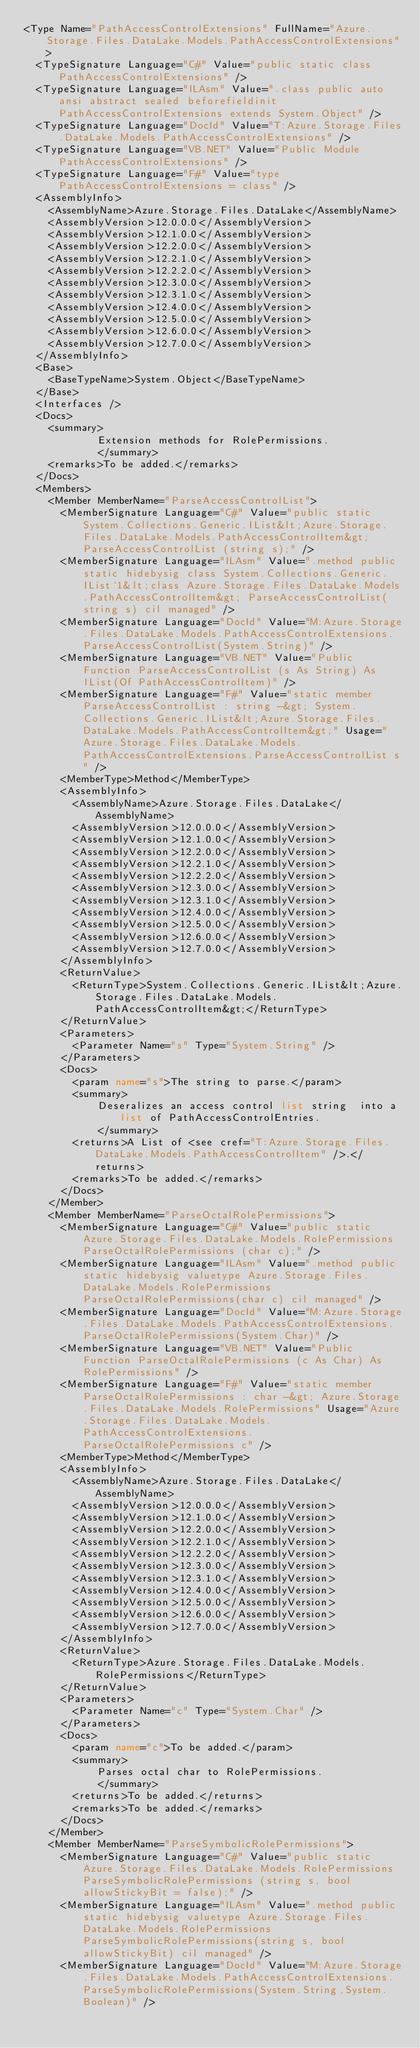Convert code to text. <code><loc_0><loc_0><loc_500><loc_500><_XML_><Type Name="PathAccessControlExtensions" FullName="Azure.Storage.Files.DataLake.Models.PathAccessControlExtensions">
  <TypeSignature Language="C#" Value="public static class PathAccessControlExtensions" />
  <TypeSignature Language="ILAsm" Value=".class public auto ansi abstract sealed beforefieldinit PathAccessControlExtensions extends System.Object" />
  <TypeSignature Language="DocId" Value="T:Azure.Storage.Files.DataLake.Models.PathAccessControlExtensions" />
  <TypeSignature Language="VB.NET" Value="Public Module PathAccessControlExtensions" />
  <TypeSignature Language="F#" Value="type PathAccessControlExtensions = class" />
  <AssemblyInfo>
    <AssemblyName>Azure.Storage.Files.DataLake</AssemblyName>
    <AssemblyVersion>12.0.0.0</AssemblyVersion>
    <AssemblyVersion>12.1.0.0</AssemblyVersion>
    <AssemblyVersion>12.2.0.0</AssemblyVersion>
    <AssemblyVersion>12.2.1.0</AssemblyVersion>
    <AssemblyVersion>12.2.2.0</AssemblyVersion>
    <AssemblyVersion>12.3.0.0</AssemblyVersion>
    <AssemblyVersion>12.3.1.0</AssemblyVersion>
    <AssemblyVersion>12.4.0.0</AssemblyVersion>
    <AssemblyVersion>12.5.0.0</AssemblyVersion>
    <AssemblyVersion>12.6.0.0</AssemblyVersion>
    <AssemblyVersion>12.7.0.0</AssemblyVersion>
  </AssemblyInfo>
  <Base>
    <BaseTypeName>System.Object</BaseTypeName>
  </Base>
  <Interfaces />
  <Docs>
    <summary>
            Extension methods for RolePermissions.
            </summary>
    <remarks>To be added.</remarks>
  </Docs>
  <Members>
    <Member MemberName="ParseAccessControlList">
      <MemberSignature Language="C#" Value="public static System.Collections.Generic.IList&lt;Azure.Storage.Files.DataLake.Models.PathAccessControlItem&gt; ParseAccessControlList (string s);" />
      <MemberSignature Language="ILAsm" Value=".method public static hidebysig class System.Collections.Generic.IList`1&lt;class Azure.Storage.Files.DataLake.Models.PathAccessControlItem&gt; ParseAccessControlList(string s) cil managed" />
      <MemberSignature Language="DocId" Value="M:Azure.Storage.Files.DataLake.Models.PathAccessControlExtensions.ParseAccessControlList(System.String)" />
      <MemberSignature Language="VB.NET" Value="Public Function ParseAccessControlList (s As String) As IList(Of PathAccessControlItem)" />
      <MemberSignature Language="F#" Value="static member ParseAccessControlList : string -&gt; System.Collections.Generic.IList&lt;Azure.Storage.Files.DataLake.Models.PathAccessControlItem&gt;" Usage="Azure.Storage.Files.DataLake.Models.PathAccessControlExtensions.ParseAccessControlList s" />
      <MemberType>Method</MemberType>
      <AssemblyInfo>
        <AssemblyName>Azure.Storage.Files.DataLake</AssemblyName>
        <AssemblyVersion>12.0.0.0</AssemblyVersion>
        <AssemblyVersion>12.1.0.0</AssemblyVersion>
        <AssemblyVersion>12.2.0.0</AssemblyVersion>
        <AssemblyVersion>12.2.1.0</AssemblyVersion>
        <AssemblyVersion>12.2.2.0</AssemblyVersion>
        <AssemblyVersion>12.3.0.0</AssemblyVersion>
        <AssemblyVersion>12.3.1.0</AssemblyVersion>
        <AssemblyVersion>12.4.0.0</AssemblyVersion>
        <AssemblyVersion>12.5.0.0</AssemblyVersion>
        <AssemblyVersion>12.6.0.0</AssemblyVersion>
        <AssemblyVersion>12.7.0.0</AssemblyVersion>
      </AssemblyInfo>
      <ReturnValue>
        <ReturnType>System.Collections.Generic.IList&lt;Azure.Storage.Files.DataLake.Models.PathAccessControlItem&gt;</ReturnType>
      </ReturnValue>
      <Parameters>
        <Parameter Name="s" Type="System.String" />
      </Parameters>
      <Docs>
        <param name="s">The string to parse.</param>
        <summary>
            Deseralizes an access control list string  into a list of PathAccessControlEntries.
            </summary>
        <returns>A List of <see cref="T:Azure.Storage.Files.DataLake.Models.PathAccessControlItem" />.</returns>
        <remarks>To be added.</remarks>
      </Docs>
    </Member>
    <Member MemberName="ParseOctalRolePermissions">
      <MemberSignature Language="C#" Value="public static Azure.Storage.Files.DataLake.Models.RolePermissions ParseOctalRolePermissions (char c);" />
      <MemberSignature Language="ILAsm" Value=".method public static hidebysig valuetype Azure.Storage.Files.DataLake.Models.RolePermissions ParseOctalRolePermissions(char c) cil managed" />
      <MemberSignature Language="DocId" Value="M:Azure.Storage.Files.DataLake.Models.PathAccessControlExtensions.ParseOctalRolePermissions(System.Char)" />
      <MemberSignature Language="VB.NET" Value="Public Function ParseOctalRolePermissions (c As Char) As RolePermissions" />
      <MemberSignature Language="F#" Value="static member ParseOctalRolePermissions : char -&gt; Azure.Storage.Files.DataLake.Models.RolePermissions" Usage="Azure.Storage.Files.DataLake.Models.PathAccessControlExtensions.ParseOctalRolePermissions c" />
      <MemberType>Method</MemberType>
      <AssemblyInfo>
        <AssemblyName>Azure.Storage.Files.DataLake</AssemblyName>
        <AssemblyVersion>12.0.0.0</AssemblyVersion>
        <AssemblyVersion>12.1.0.0</AssemblyVersion>
        <AssemblyVersion>12.2.0.0</AssemblyVersion>
        <AssemblyVersion>12.2.1.0</AssemblyVersion>
        <AssemblyVersion>12.2.2.0</AssemblyVersion>
        <AssemblyVersion>12.3.0.0</AssemblyVersion>
        <AssemblyVersion>12.3.1.0</AssemblyVersion>
        <AssemblyVersion>12.4.0.0</AssemblyVersion>
        <AssemblyVersion>12.5.0.0</AssemblyVersion>
        <AssemblyVersion>12.6.0.0</AssemblyVersion>
        <AssemblyVersion>12.7.0.0</AssemblyVersion>
      </AssemblyInfo>
      <ReturnValue>
        <ReturnType>Azure.Storage.Files.DataLake.Models.RolePermissions</ReturnType>
      </ReturnValue>
      <Parameters>
        <Parameter Name="c" Type="System.Char" />
      </Parameters>
      <Docs>
        <param name="c">To be added.</param>
        <summary>
            Parses octal char to RolePermissions.
            </summary>
        <returns>To be added.</returns>
        <remarks>To be added.</remarks>
      </Docs>
    </Member>
    <Member MemberName="ParseSymbolicRolePermissions">
      <MemberSignature Language="C#" Value="public static Azure.Storage.Files.DataLake.Models.RolePermissions ParseSymbolicRolePermissions (string s, bool allowStickyBit = false);" />
      <MemberSignature Language="ILAsm" Value=".method public static hidebysig valuetype Azure.Storage.Files.DataLake.Models.RolePermissions ParseSymbolicRolePermissions(string s, bool allowStickyBit) cil managed" />
      <MemberSignature Language="DocId" Value="M:Azure.Storage.Files.DataLake.Models.PathAccessControlExtensions.ParseSymbolicRolePermissions(System.String,System.Boolean)" /></code> 